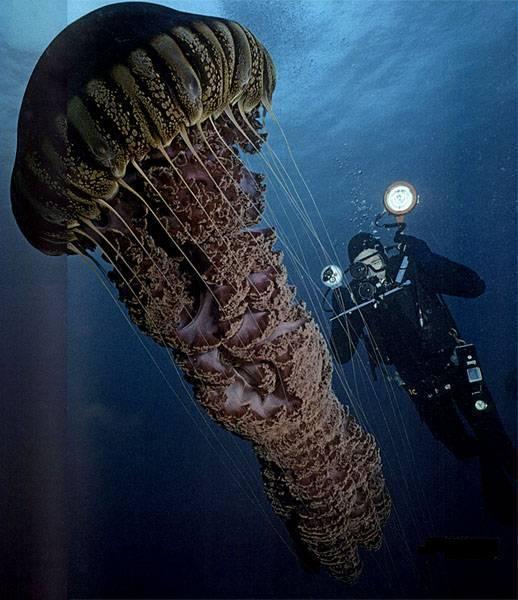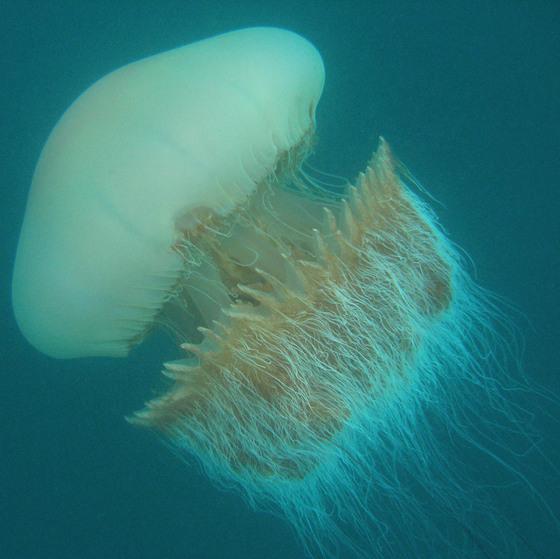The first image is the image on the left, the second image is the image on the right. Examine the images to the left and right. Is the description "One image in the pair shows a single jellyfish and the other shows a scuba diver with a single jellyfish." accurate? Answer yes or no. Yes. The first image is the image on the left, the second image is the image on the right. For the images shown, is this caption "One image shows a person in a scuba suit holding something up next to a large mushroom-capped jellyfish with its tentacles trailing diagonally downward to the right." true? Answer yes or no. Yes. 